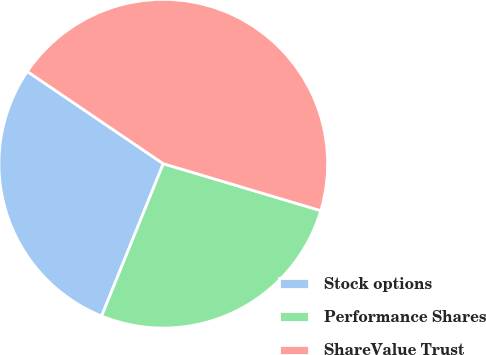Convert chart. <chart><loc_0><loc_0><loc_500><loc_500><pie_chart><fcel>Stock options<fcel>Performance Shares<fcel>ShareValue Trust<nl><fcel>28.37%<fcel>26.51%<fcel>45.13%<nl></chart> 